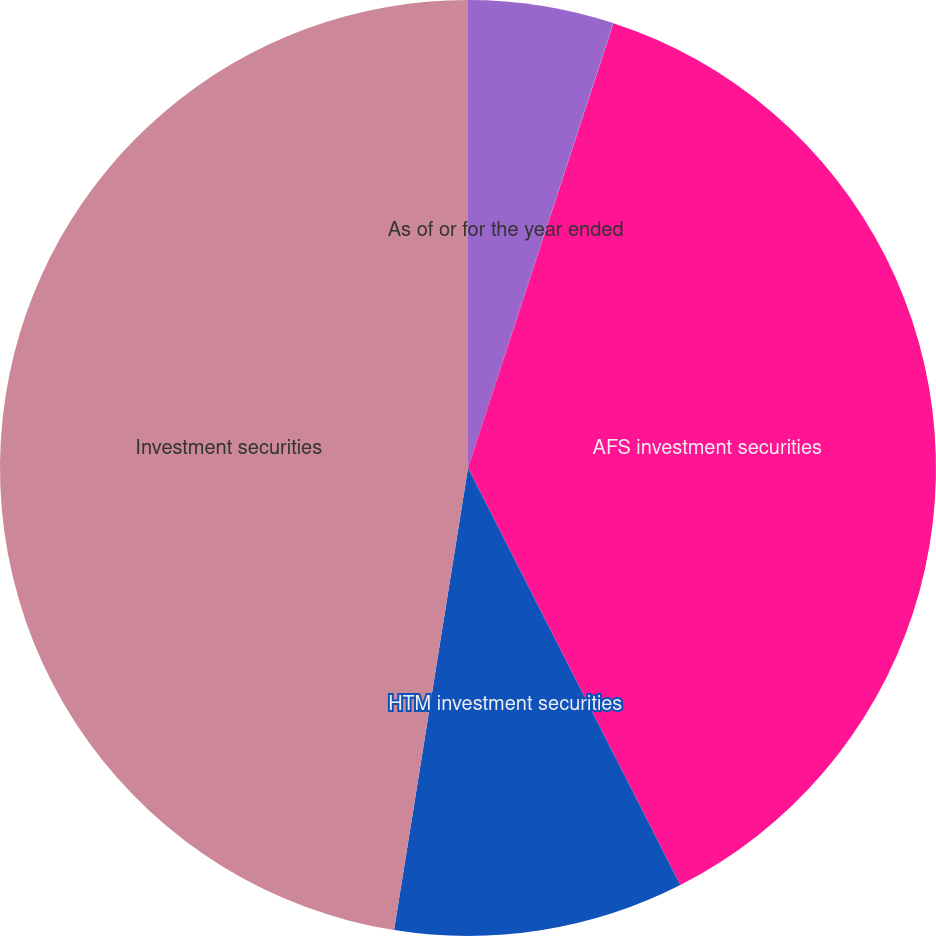Convert chart. <chart><loc_0><loc_0><loc_500><loc_500><pie_chart><fcel>As of or for the year ended<fcel>Securities gains/(losses)<fcel>AFS investment securities<fcel>HTM investment securities<fcel>Investment securities<nl><fcel>5.02%<fcel>0.01%<fcel>37.48%<fcel>10.02%<fcel>47.48%<nl></chart> 